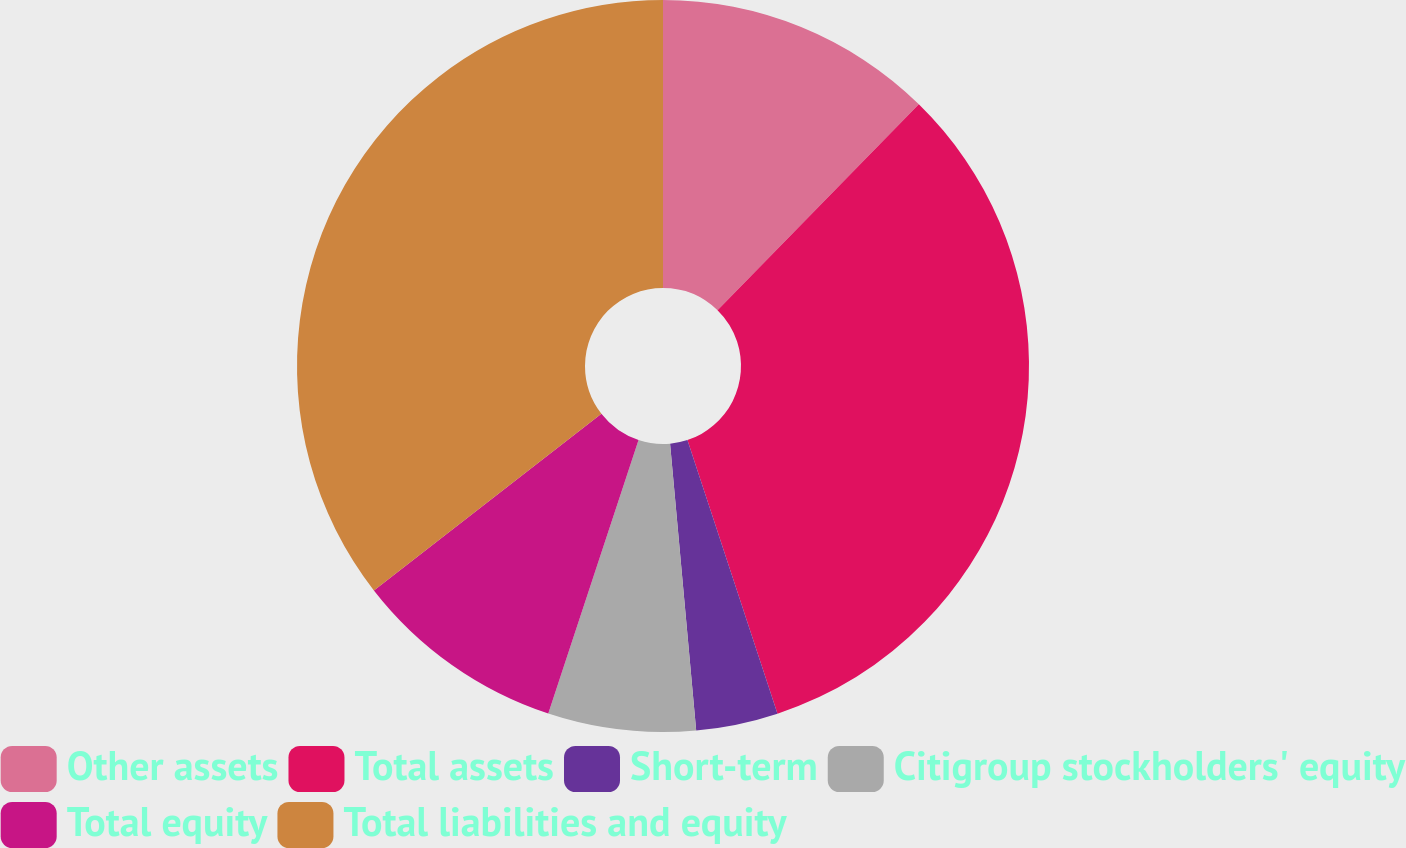Convert chart. <chart><loc_0><loc_0><loc_500><loc_500><pie_chart><fcel>Other assets<fcel>Total assets<fcel>Short-term<fcel>Citigroup stockholders' equity<fcel>Total equity<fcel>Total liabilities and equity<nl><fcel>12.32%<fcel>32.62%<fcel>3.62%<fcel>6.52%<fcel>9.42%<fcel>35.51%<nl></chart> 